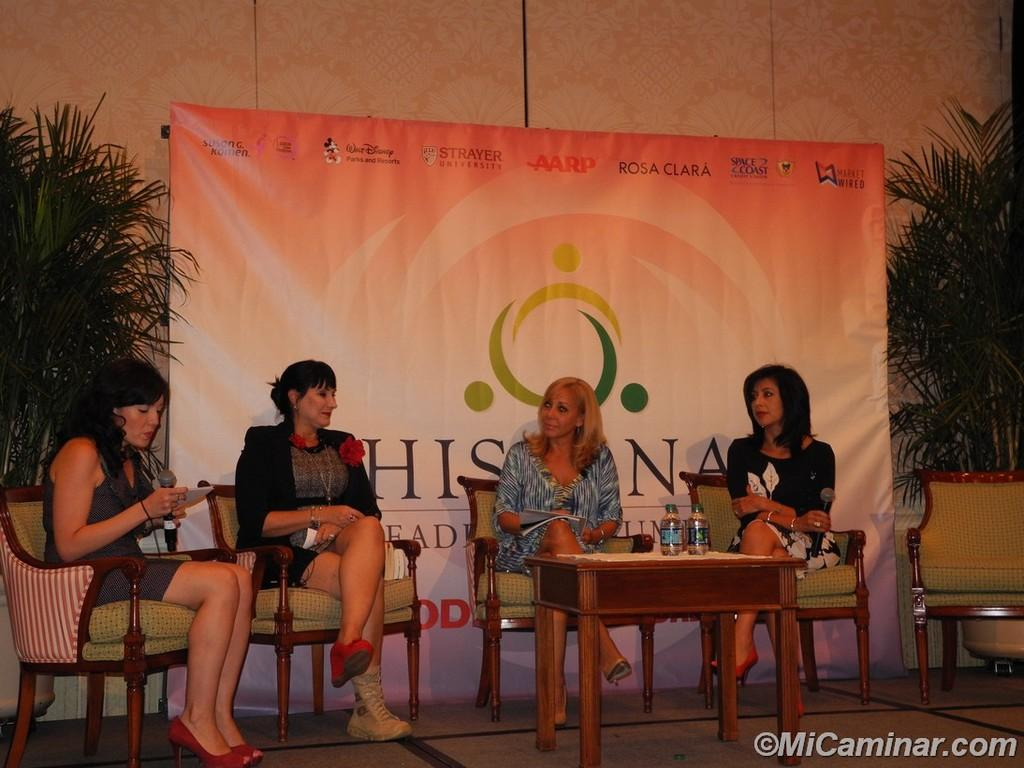What is the main subject of the image? The main subject of the image is a group of women. What are the women doing in the image? The women are sitting on chairs in the image. Where are the chairs located in relation to the table? The chairs are in front of a table in the image. What can be seen in the background of the image? There is a banner visible in the background, as well as plants on the floor. What type of blood is visible on the table in the image? There is no blood visible on the table in the image. How does the earth contribute to the atmosphere of the image? The image does not depict any elements related to the earth, so it cannot be determined how the earth contributes to the atmosphere of the image. 